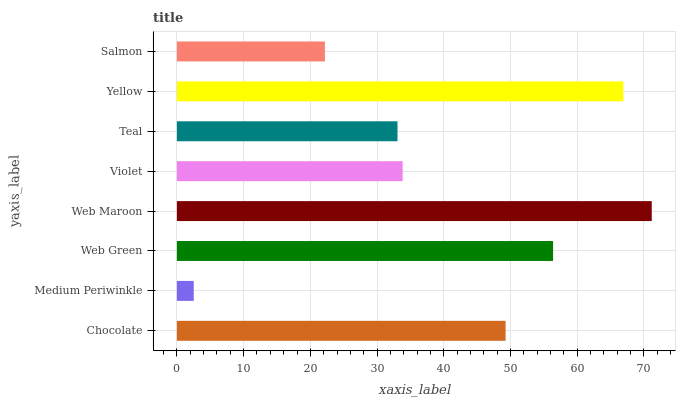Is Medium Periwinkle the minimum?
Answer yes or no. Yes. Is Web Maroon the maximum?
Answer yes or no. Yes. Is Web Green the minimum?
Answer yes or no. No. Is Web Green the maximum?
Answer yes or no. No. Is Web Green greater than Medium Periwinkle?
Answer yes or no. Yes. Is Medium Periwinkle less than Web Green?
Answer yes or no. Yes. Is Medium Periwinkle greater than Web Green?
Answer yes or no. No. Is Web Green less than Medium Periwinkle?
Answer yes or no. No. Is Chocolate the high median?
Answer yes or no. Yes. Is Violet the low median?
Answer yes or no. Yes. Is Web Maroon the high median?
Answer yes or no. No. Is Web Green the low median?
Answer yes or no. No. 